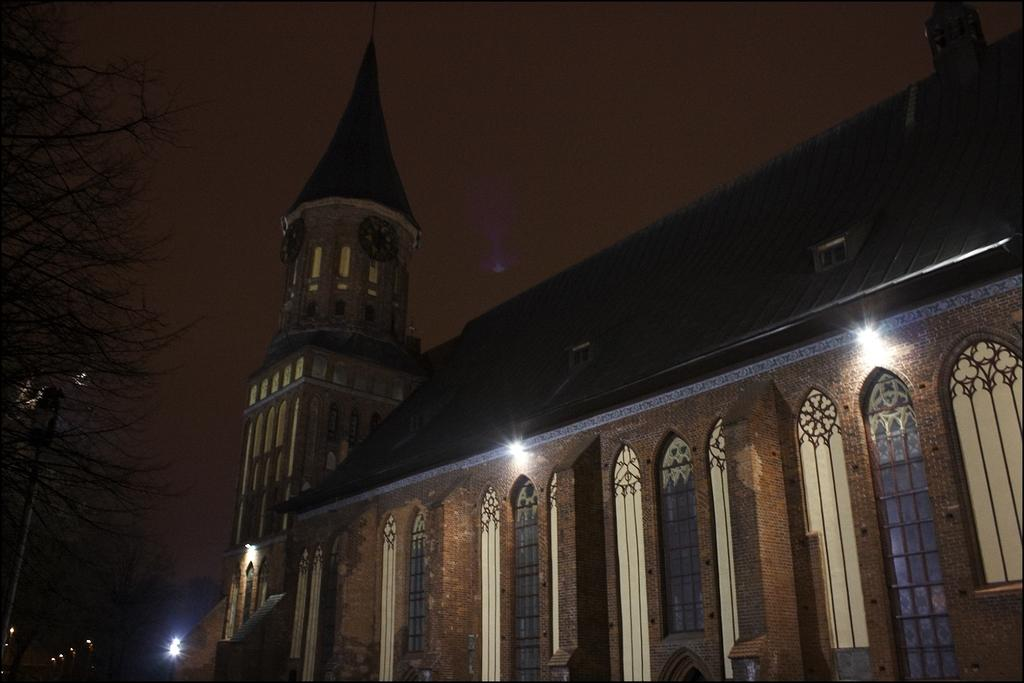What type of structure is visible in the image? There is a building with windows in the image. What additional feature can be seen on the building? There is a clock tower on the building. What can be seen illuminated in the image? There are lights visible in the image. What type of vegetation is present in the image? There are trees in the image. What other object can be seen in the image? There is a pole in the image. What is visible in the background of the image? The sky is visible in the image. Where is the grandmother sitting in the image? There is no grandmother present in the image. How many pages are visible in the image? There are no pages visible in the image. 